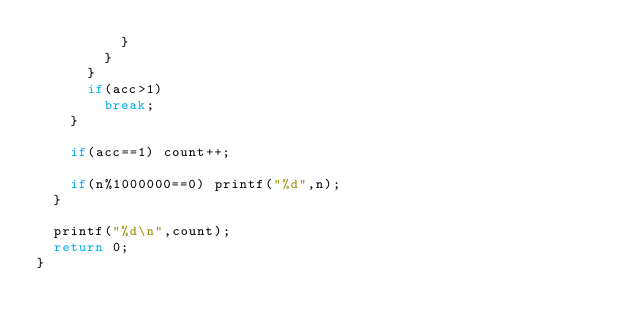<code> <loc_0><loc_0><loc_500><loc_500><_C++_>					}
				}
			}
			if(acc>1)
				break;
		}

		if(acc==1) count++;
		
		if(n%1000000==0) printf("%d",n);
	}
	
	printf("%d\n",count);
	return 0;
}</code> 